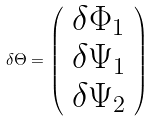<formula> <loc_0><loc_0><loc_500><loc_500>\delta \Theta = \left ( \begin{array} { c } \delta \Phi _ { 1 } \\ \delta \Psi _ { 1 } \\ \delta \Psi _ { 2 } \end{array} \right )</formula> 